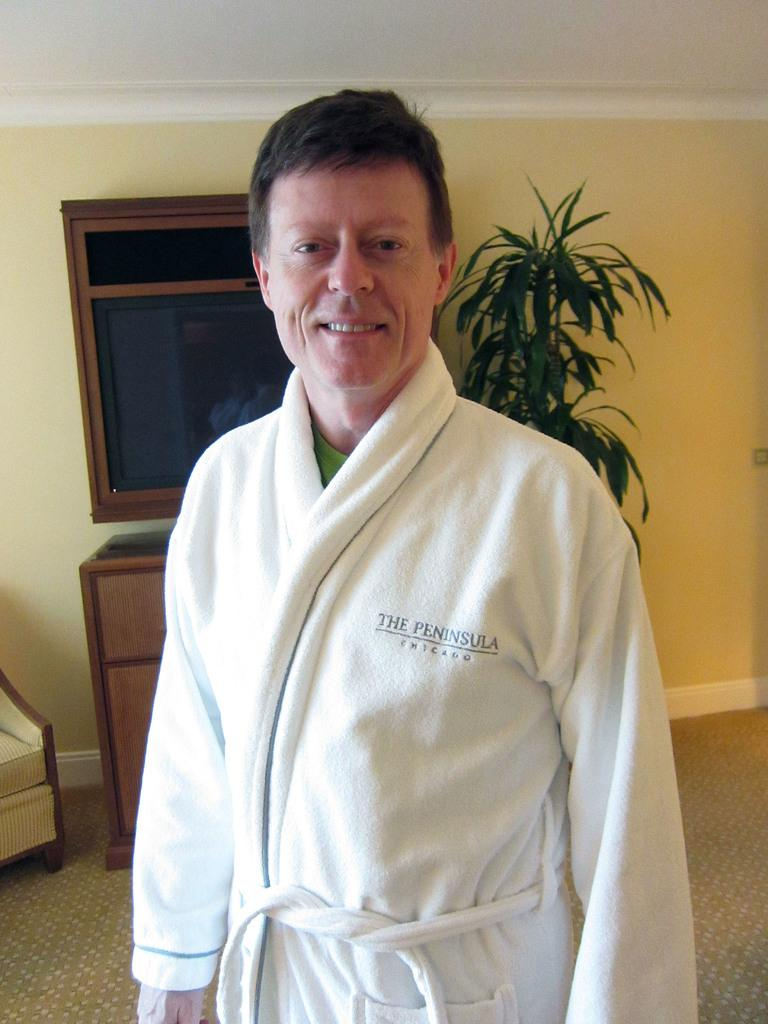<image>
Give a short and clear explanation of the subsequent image. Man wearing a white robe which says "The Peninsula" on it. 